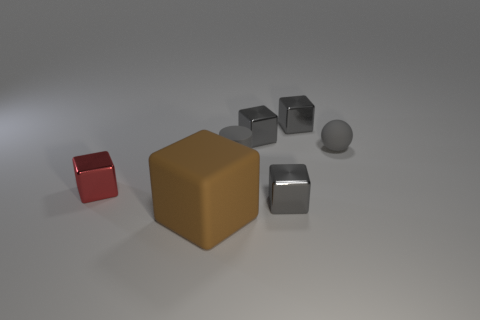Which object in the image seems to reflect light most intensely? The object reflecting light most intensely appears to be the small, polished red cube. Its surface is catching the light, resulting in bright highlights and a vivid color. 